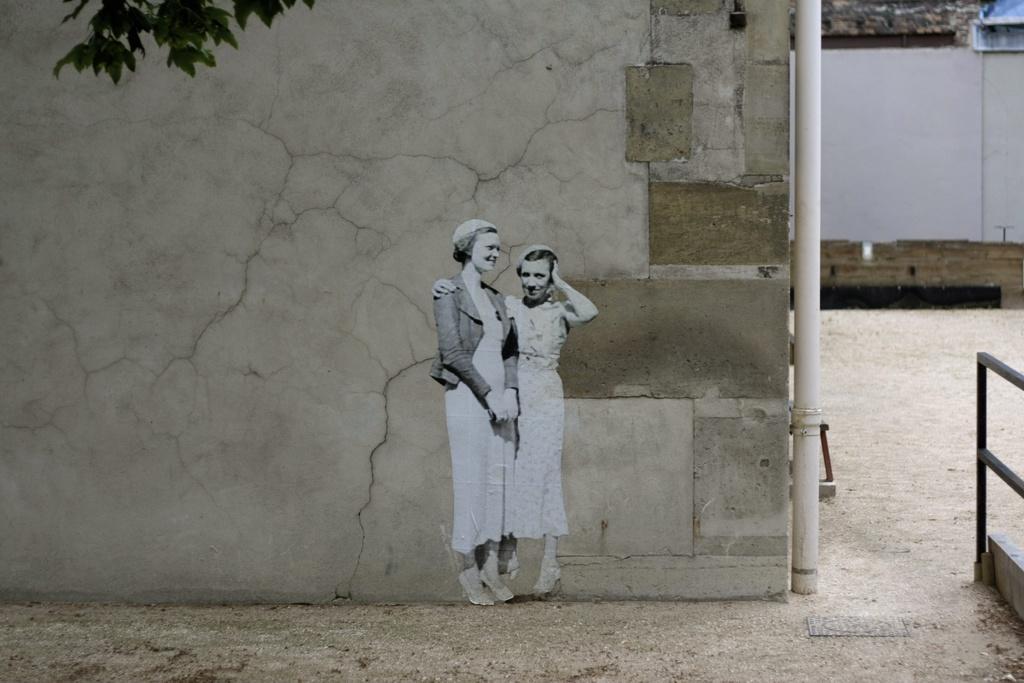Please provide a concise description of this image. In this image I can see two women standing on the ground. In the background I can see the wall, a pipe, a building, the railing and to the left top of the image I can see the tree. 